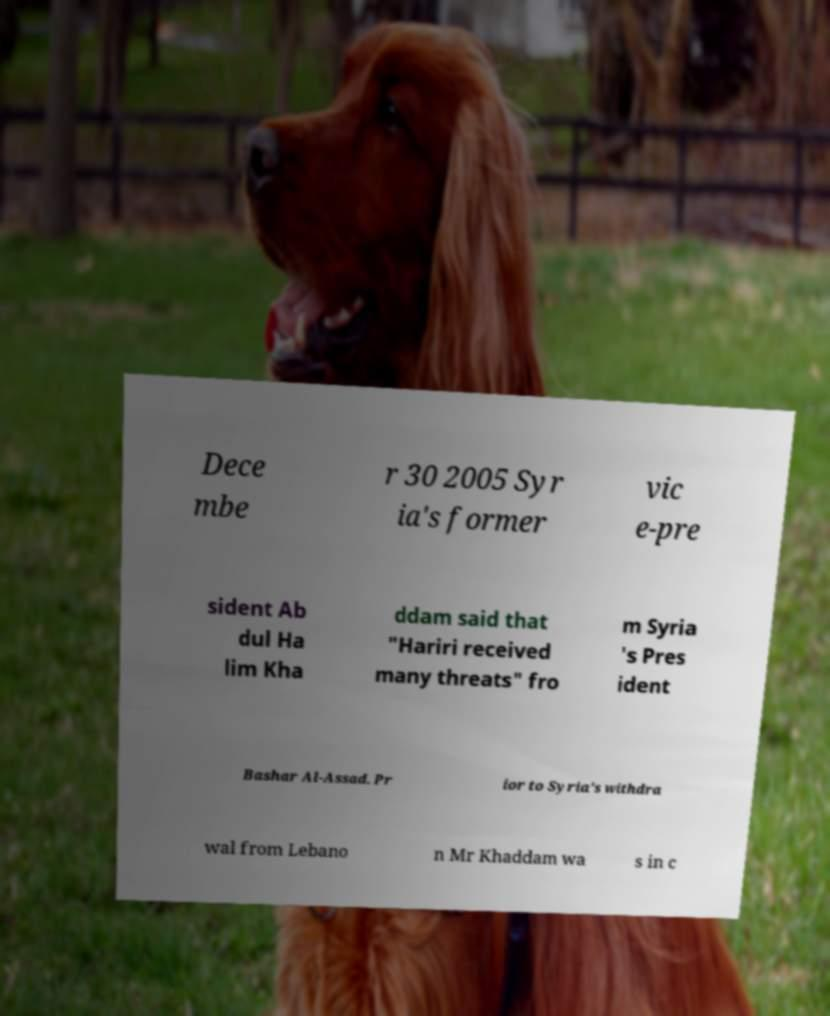Can you read and provide the text displayed in the image?This photo seems to have some interesting text. Can you extract and type it out for me? Dece mbe r 30 2005 Syr ia's former vic e-pre sident Ab dul Ha lim Kha ddam said that "Hariri received many threats" fro m Syria 's Pres ident Bashar Al-Assad. Pr ior to Syria's withdra wal from Lebano n Mr Khaddam wa s in c 